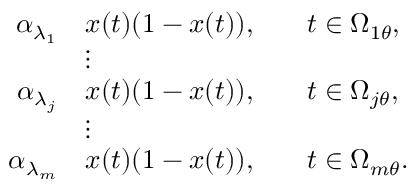<formula> <loc_0><loc_0><loc_500><loc_500>\begin{array} { r l r l } { \alpha _ { \lambda _ { 1 } } } & { x ( t ) ( 1 - x ( t ) ) , } & & { t \in \Omega _ { 1 \theta } , } \\ & { \vdots } & \\ { \alpha _ { \lambda _ { j } } } & { x ( t ) ( 1 - x ( t ) ) , } & & { t \in \Omega _ { j \theta } , } \\ & { \vdots } & \\ { \alpha _ { \lambda _ { m } } } & { x ( t ) ( 1 - x ( t ) ) , } & & { t \in \Omega _ { m \theta } . } \end{array}</formula> 